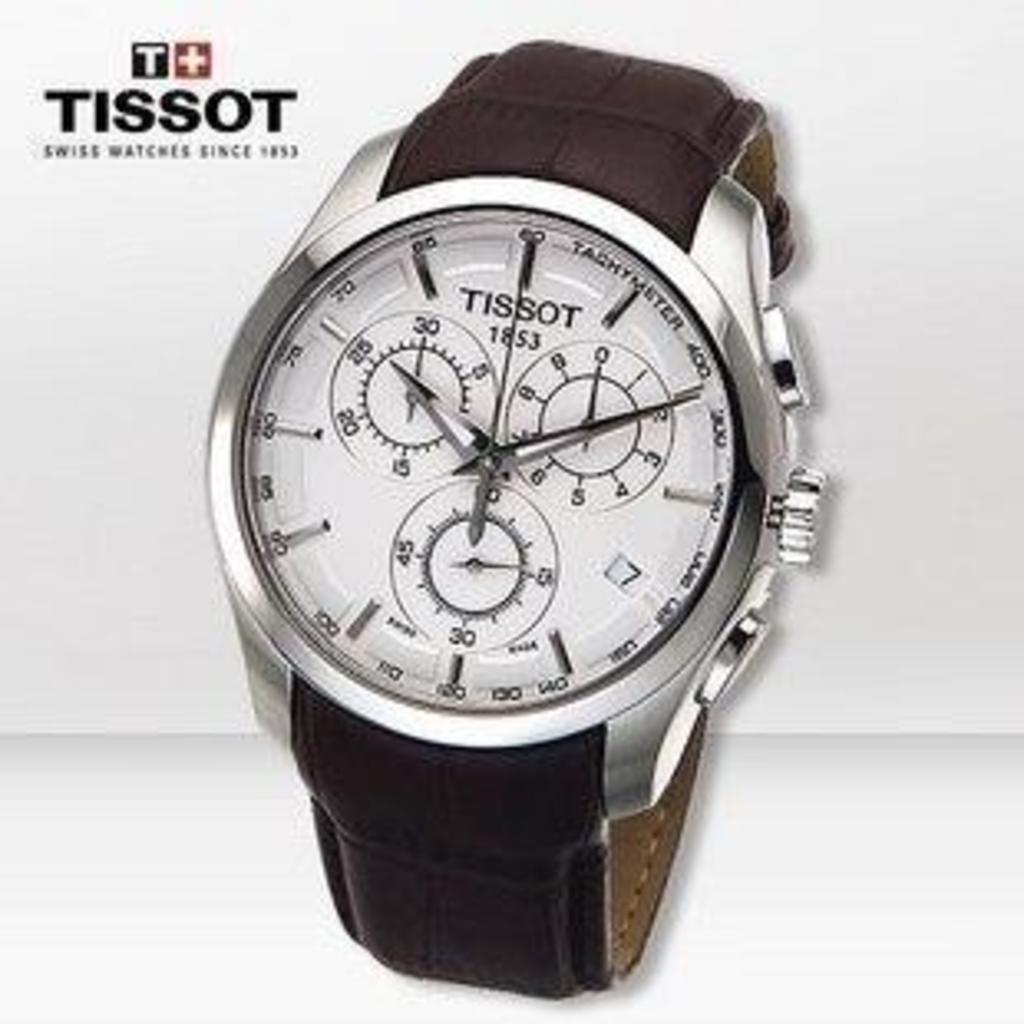<image>
Provide a brief description of the given image. A watch from Tissot has a leather strap and is on a white backdrop. 